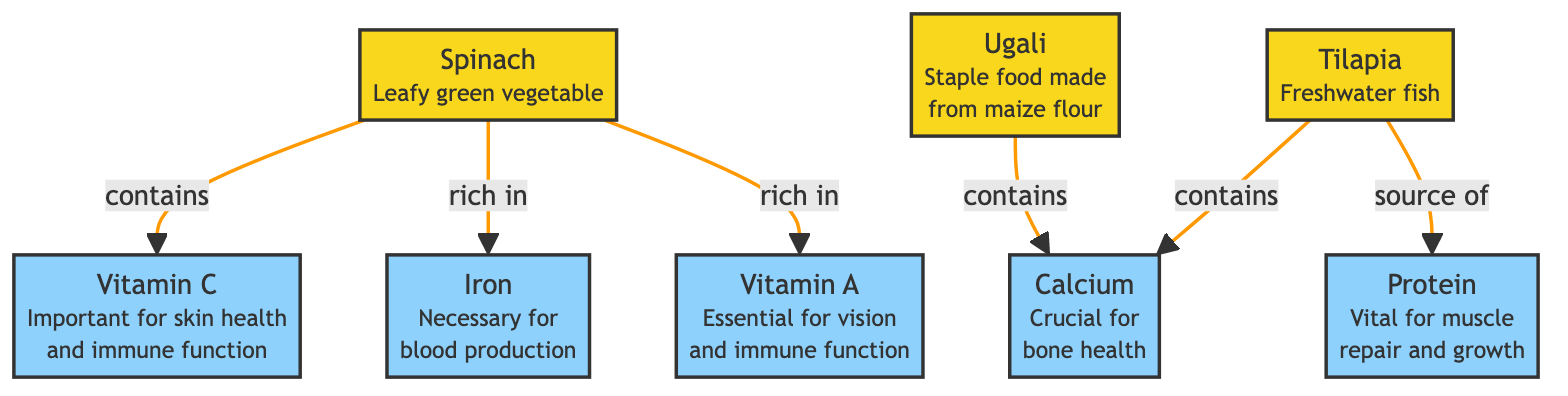What food is a staple made from maize flour? The diagram identifies ugali as the food that is a staple made from maize flour, specified directly in the node description for ugali.
Answer: ugali Which nutrient is crucial for bone health? The diagram clearly indicates that calcium is the nutrient specifically linked to bone health, as shown in the calcium node description.
Answer: calcium How many foods are listed in the diagram? By counting the food nodes in the diagram, we see three distinct food items: ugali, spinach, and tilapia, confirming the total number.
Answer: 3 What vitamin is rich in spinach? The diagram indicates that spinach is rich in vitamin A, which is clearly labeled in the relationships from the spinach node to the vitamin A node.
Answer: vitamin A Which food contains calcium? The diagram shows that both ugali and tilapia are associated with calcium, as indicated by the directed arrows reaching the calcium node from both food nodes.
Answer: ugali, tilapia What is the importance of Vitamin C according to the diagram? The diagram illustrates that vitamin C is important for skin health and immune function, detailed in the description of the vitamin C node.
Answer: skin health and immune function Which food is a source of protein? The diagram specifies that tilapia is a source of protein, as indicated by the arrow leading from the tilapia node to the protein node.
Answer: tilapia How many nutrients are linked to spinach? The diagram indicates that spinach is linked to three nutrients: vitamin A, iron, and vitamin C, so we can count these relationships.
Answer: 3 What is the relationship between ugali and calcium? The diagram shows a direct link from ugali to calcium, indicating that ugali contains calcium, clearly delineated by the arrow and label.
Answer: contains What function do the nutrient nodes serve in the diagram? The nutrient nodes serve to represent the specific health benefits associated with each nutrient, elaborated in their respective descriptions, answering the purpose of illustrating nutritional benefits.
Answer: nutritional benefits 